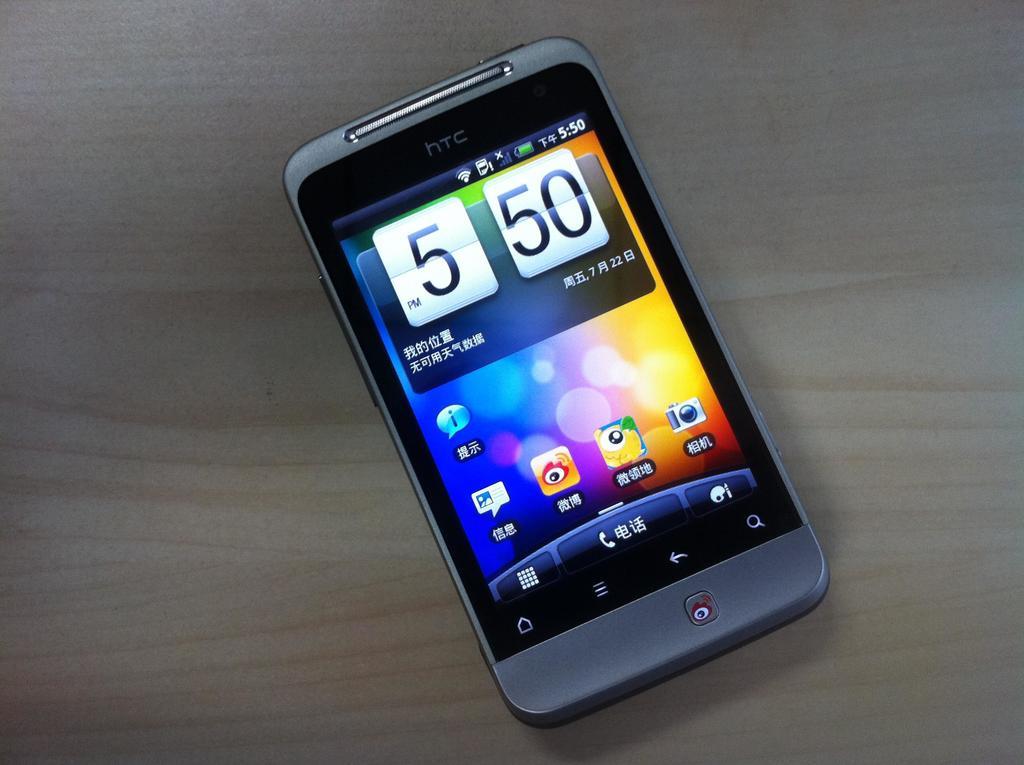In what language is this phone?
Your answer should be compact. Unanswerable. 